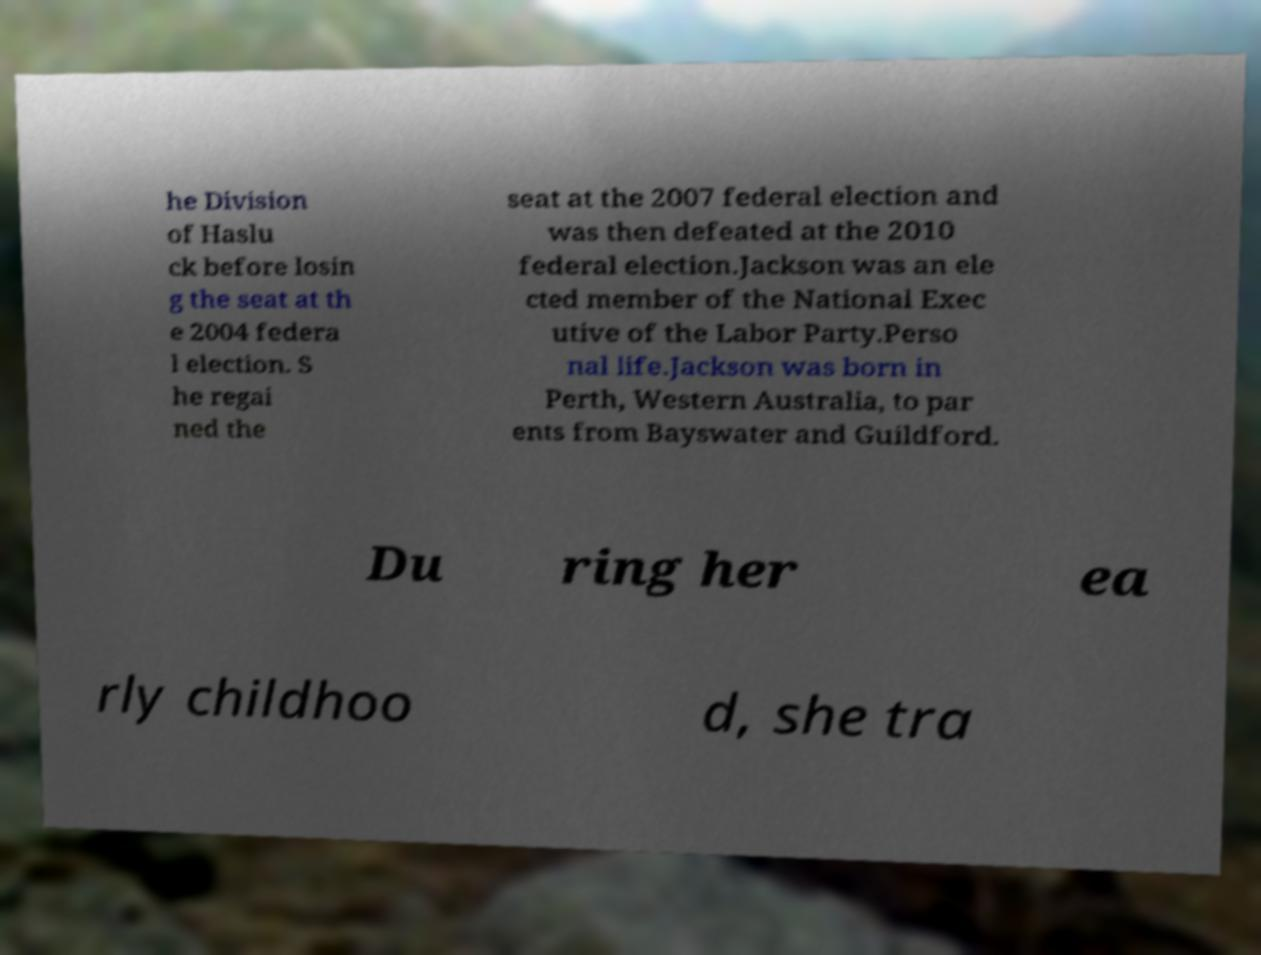Could you assist in decoding the text presented in this image and type it out clearly? he Division of Haslu ck before losin g the seat at th e 2004 federa l election. S he regai ned the seat at the 2007 federal election and was then defeated at the 2010 federal election.Jackson was an ele cted member of the National Exec utive of the Labor Party.Perso nal life.Jackson was born in Perth, Western Australia, to par ents from Bayswater and Guildford. Du ring her ea rly childhoo d, she tra 